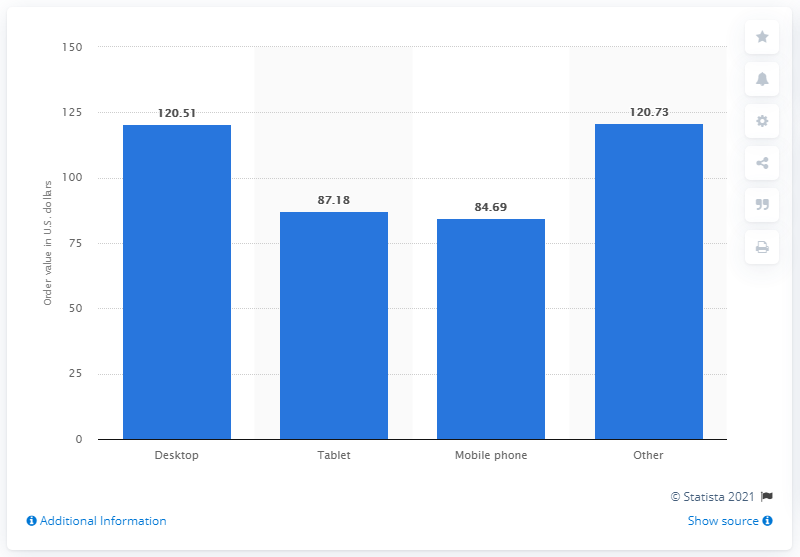Point out several critical features in this image. The average value of online orders placed from a mobile phone in the third quarter of 2020 was 84.69. 